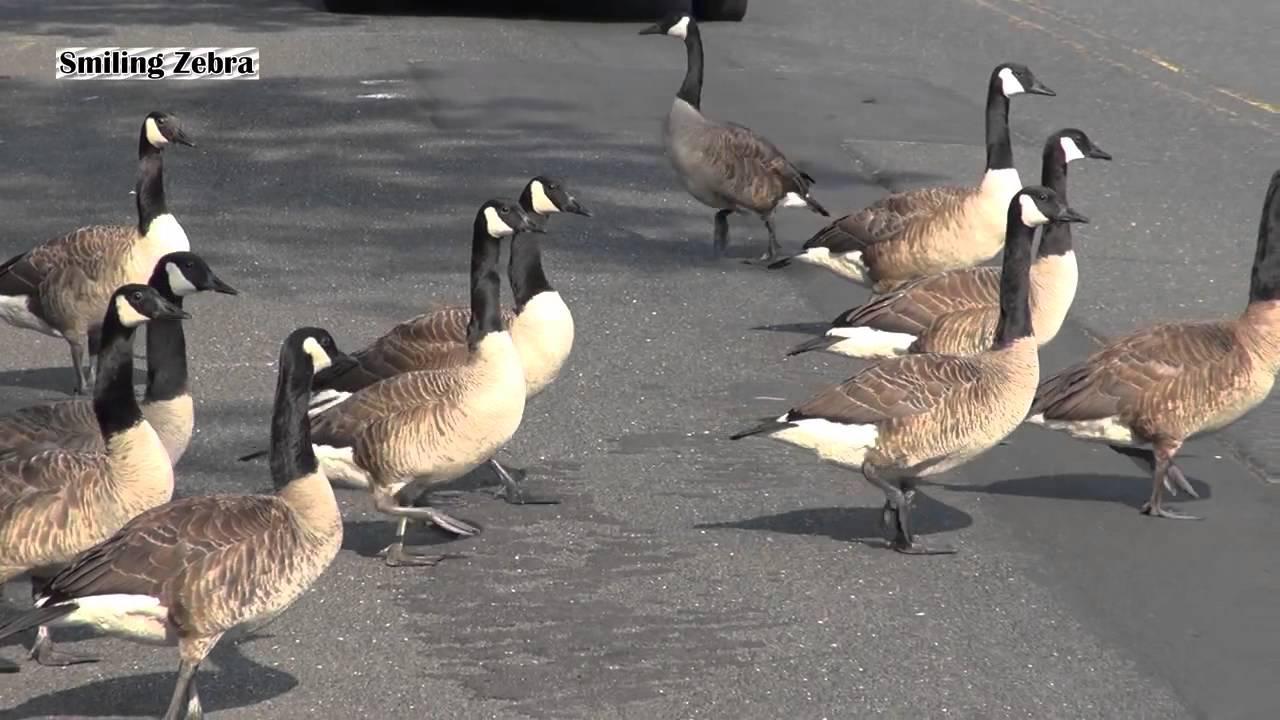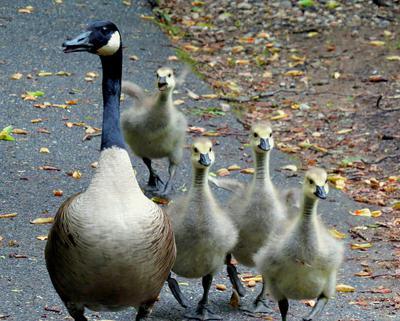The first image is the image on the left, the second image is the image on the right. Considering the images on both sides, is "A goose has a horn-like projection above its beak, and the only bird in the foreground of the image on the right is white." valid? Answer yes or no. No. The first image is the image on the left, the second image is the image on the right. Evaluate the accuracy of this statement regarding the images: "there is a single goose with a knob on it's forehead". Is it true? Answer yes or no. No. 